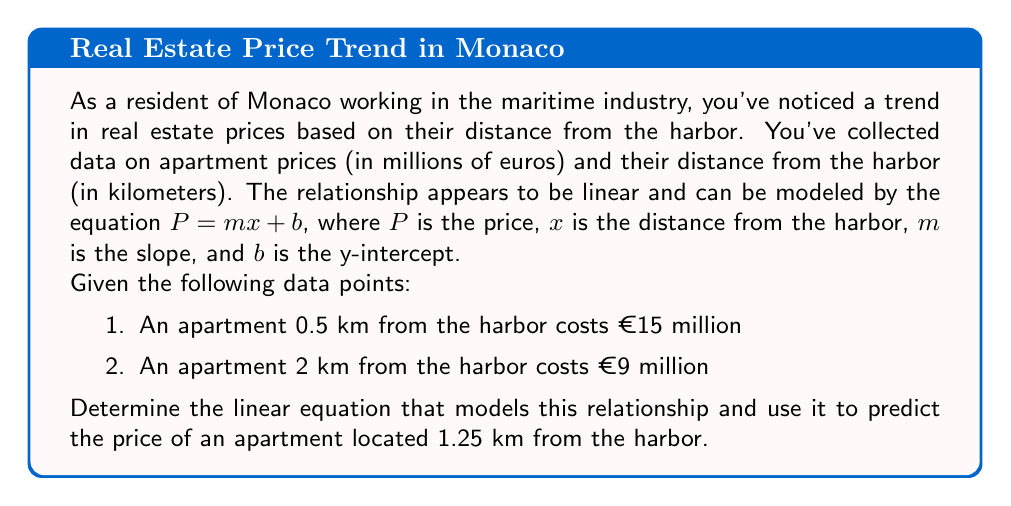Could you help me with this problem? Let's approach this step-by-step:

1) We have two points: (0.5, 15) and (2, 9)

2) To find the slope (m), we use the formula:
   $$m = \frac{y_2 - y_1}{x_2 - x_1} = \frac{9 - 15}{2 - 0.5} = \frac{-6}{1.5} = -4$$

3) Now we know that for every 1 km increase in distance from the harbor, the price decreases by €4 million.

4) To find the y-intercept (b), we can use either point. Let's use (0.5, 15):
   $$15 = -4(0.5) + b$$
   $$15 = -2 + b$$
   $$b = 17$$

5) So our equation is:
   $$P = -4x + 17$$

6) To find the price of an apartment 1.25 km from the harbor, we substitute x = 1.25:
   $$P = -4(1.25) + 17$$
   $$P = -5 + 17 = 12$$
Answer: The linear equation modeling the relationship between apartment prices and distance from the harbor in Monaco is $P = -4x + 17$, where $P$ is the price in millions of euros and $x$ is the distance from the harbor in kilometers. Using this equation, an apartment located 1.25 km from the harbor would be predicted to cost €12 million. 